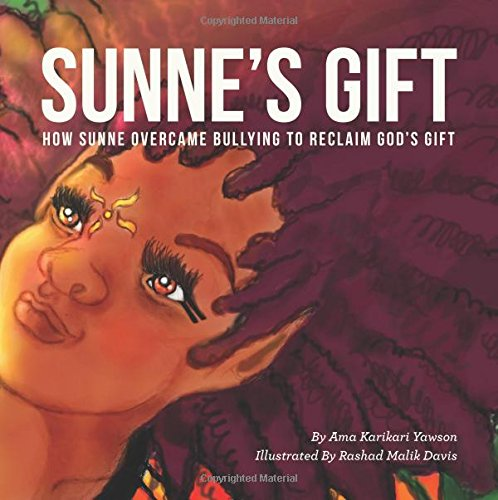Can you describe the illustration style used in this book? The illustration style in 'Sunne's Gift' is vibrant and expressive, using rich colors and dynamic characters to convey emotional depth and cultural richness, likely appealing to young children's visual senses. 